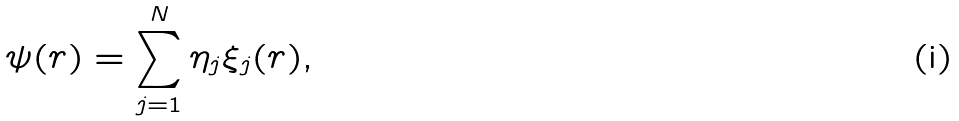<formula> <loc_0><loc_0><loc_500><loc_500>\psi ( { r } ) = \sum _ { j = 1 } ^ { N } \eta _ { j } \xi _ { j } ( { r } ) ,</formula> 